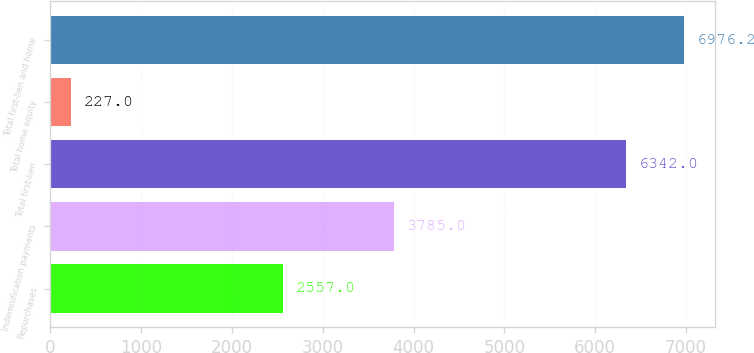Convert chart. <chart><loc_0><loc_0><loc_500><loc_500><bar_chart><fcel>Repurchases<fcel>Indemnification payments<fcel>Total first-lien<fcel>Total home equity<fcel>Total first-lien and home<nl><fcel>2557<fcel>3785<fcel>6342<fcel>227<fcel>6976.2<nl></chart> 